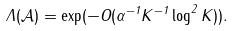<formula> <loc_0><loc_0><loc_500><loc_500>\Lambda ( \mathcal { A } ) = \exp ( - O ( \alpha ^ { - 1 } K ^ { - 1 } \log ^ { 2 } K ) ) .</formula> 